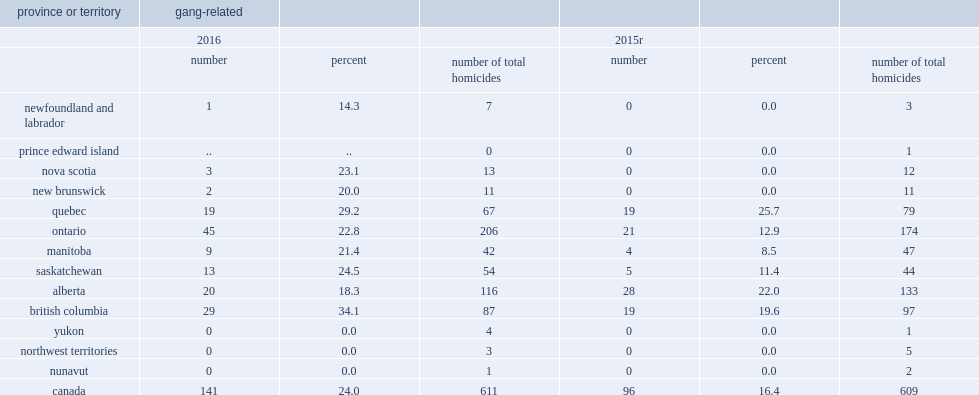What were the percentages of gang-related in saskatchewan in 2016 and 2015 respectively? 24.5 11.4. 